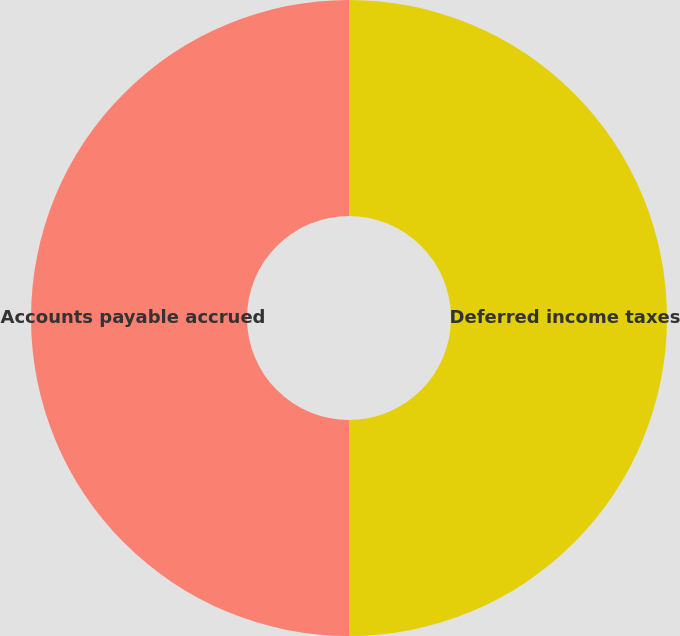Convert chart to OTSL. <chart><loc_0><loc_0><loc_500><loc_500><pie_chart><fcel>Deferred income taxes<fcel>Accounts payable accrued<nl><fcel>50.0%<fcel>50.0%<nl></chart> 